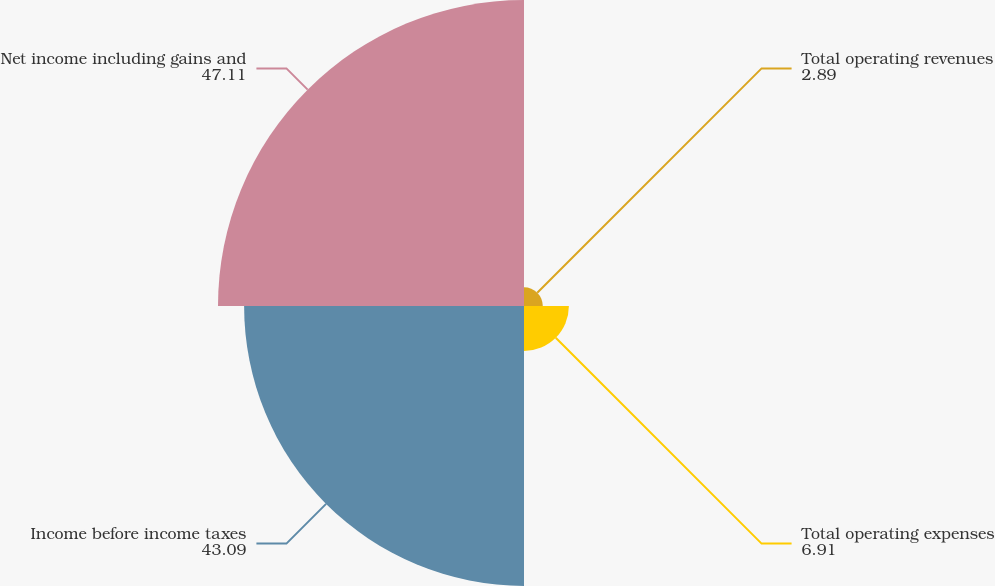Convert chart to OTSL. <chart><loc_0><loc_0><loc_500><loc_500><pie_chart><fcel>Total operating revenues<fcel>Total operating expenses<fcel>Income before income taxes<fcel>Net income including gains and<nl><fcel>2.89%<fcel>6.91%<fcel>43.09%<fcel>47.11%<nl></chart> 